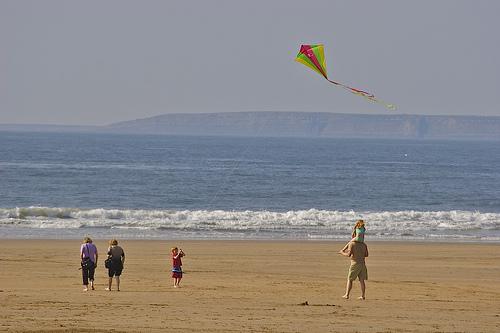How old is this boy?
Keep it brief. 4. What are the people carrying over their heads?
Write a very short answer. Kite. What does the guy in the foreground have on his shoulders?
Write a very short answer. Child. What colors make up the kite in the air?
Be succinct. Pink, green and yellow. Is the person trying to surf?
Give a very brief answer. No. How many people do you see?
Answer briefly. 5. Is the man wearing shoes?
Short answer required. No. Who is flying the kite?
Write a very short answer. Child. How many people or in the pic?
Answer briefly. 5. Is it evening?
Give a very brief answer. No. Will the little boy be able to handle the kite by himself?
Concise answer only. Yes. 